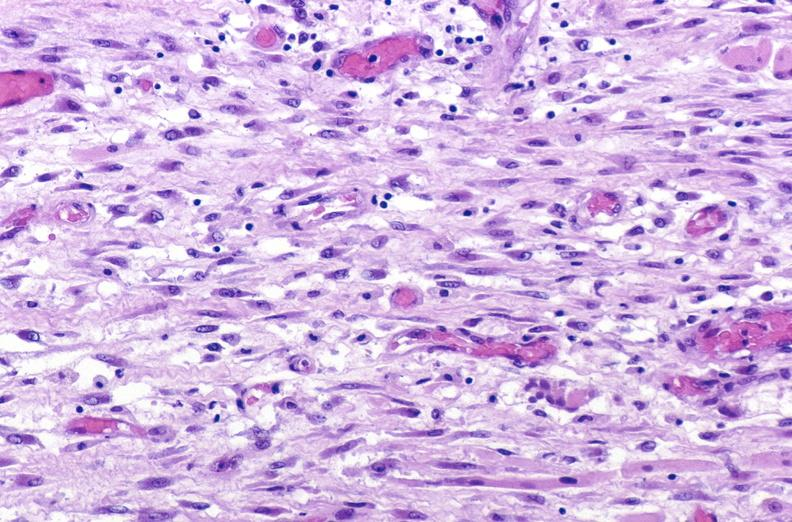does placenta show tracheotomy site, granulation tissue?
Answer the question using a single word or phrase. No 